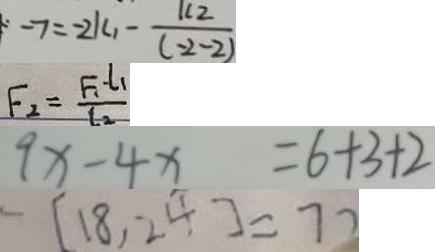<formula> <loc_0><loc_0><loc_500><loc_500>- 7 = - 2 k _ { 1 } - \frac { k 2 } { ( - 2 - 2 ) } 
 F _ { 2 } = \frac { F _ { 1 } \cdot l _ { 1 } } { l _ { 2 } } 
 9 x - 4 x = 6 + 3 + 2 
 - [ 1 8 , 2 4 ] = 7 2</formula> 